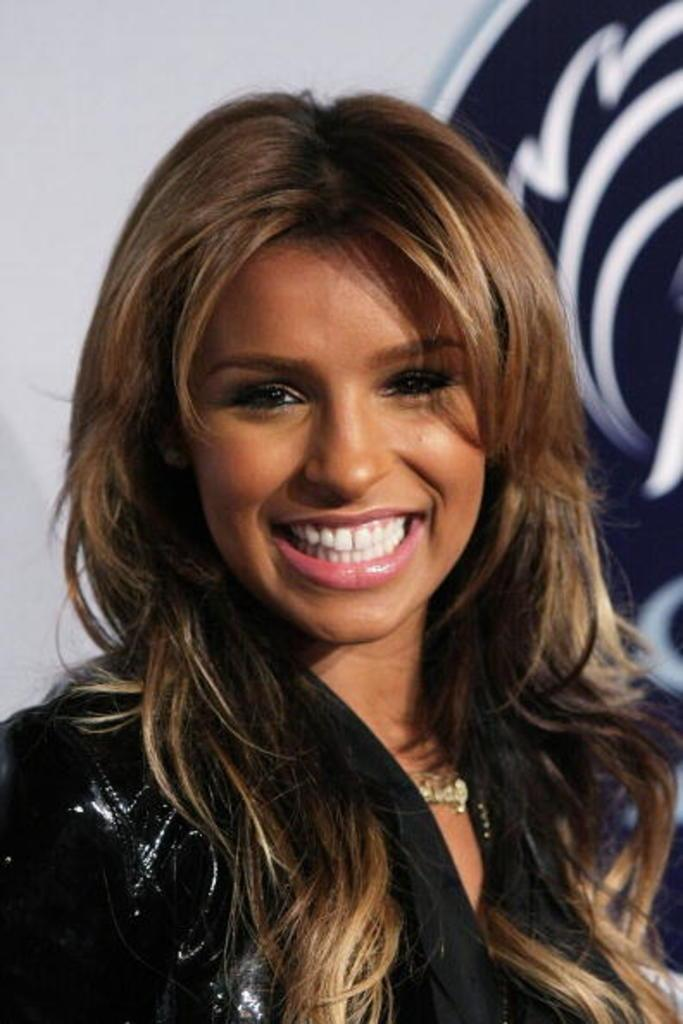What is the main subject of the image? There is a person in the image. What is the person doing in the image? The person is smiling. What color is the dress the person is wearing? The person is wearing a black color dress. What colors are used in the background of the image? The background of the image is in white and black color. Is the person in the image attending a meeting? There is no indication of a meeting in the image; it only shows a person smiling while wearing a black dress. Is the person in the image driving a vehicle? There is no vehicle or driving activity present in the image; it only shows a person standing or sitting. 